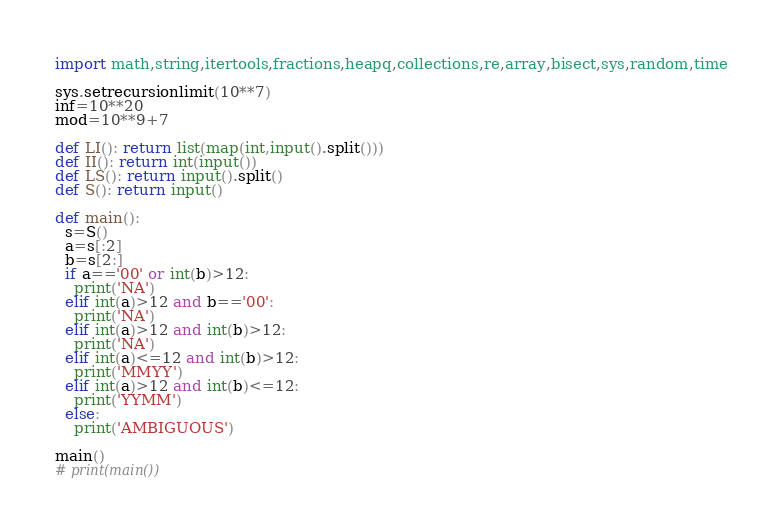<code> <loc_0><loc_0><loc_500><loc_500><_Python_>import math,string,itertools,fractions,heapq,collections,re,array,bisect,sys,random,time

sys.setrecursionlimit(10**7)
inf=10**20
mod=10**9+7

def LI(): return list(map(int,input().split()))
def II(): return int(input())
def LS(): return input().split()
def S(): return input()

def main():
  s=S()
  a=s[:2]
  b=s[2:]
  if a=='00' or int(b)>12:
    print('NA')
  elif int(a)>12 and b=='00':
    print('NA')
  elif int(a)>12 and int(b)>12:
    print('NA')
  elif int(a)<=12 and int(b)>12:
    print('MMYY')
  elif int(a)>12 and int(b)<=12:
    print('YYMM')
  else:
    print('AMBIGUOUS')

main()
# print(main())
</code> 